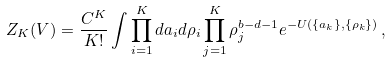<formula> <loc_0><loc_0><loc_500><loc_500>Z _ { K } ( V ) = \frac { C ^ { K } } { K ! } \int \prod _ { i = 1 } ^ { K } d { a } _ { i } d \rho _ { i } \prod _ { j = 1 } ^ { K } \rho _ { j } ^ { b - d - 1 } e ^ { - U ( \{ { a } _ { k } \} , \{ \rho _ { k } \} ) } \, ,</formula> 